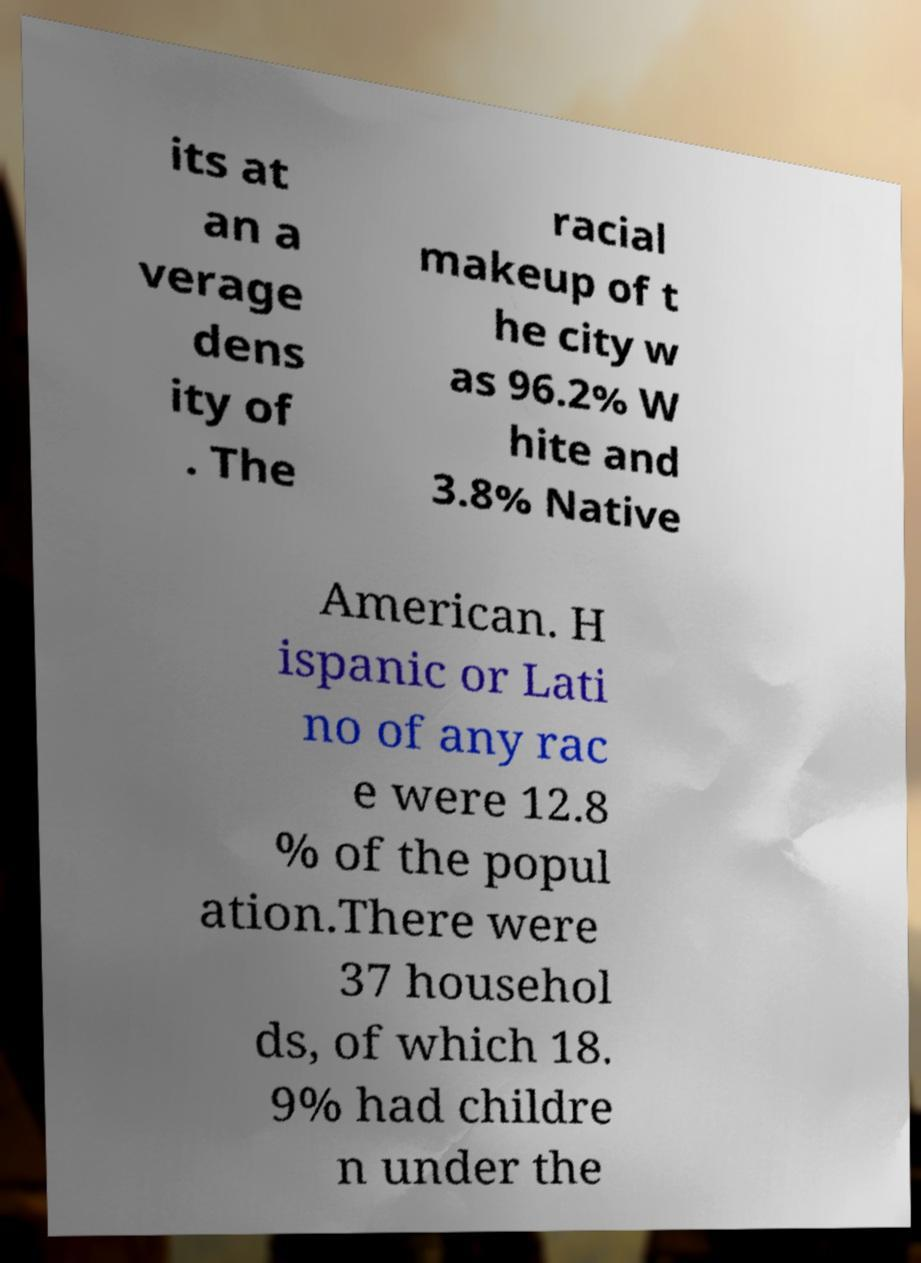For documentation purposes, I need the text within this image transcribed. Could you provide that? its at an a verage dens ity of . The racial makeup of t he city w as 96.2% W hite and 3.8% Native American. H ispanic or Lati no of any rac e were 12.8 % of the popul ation.There were 37 househol ds, of which 18. 9% had childre n under the 